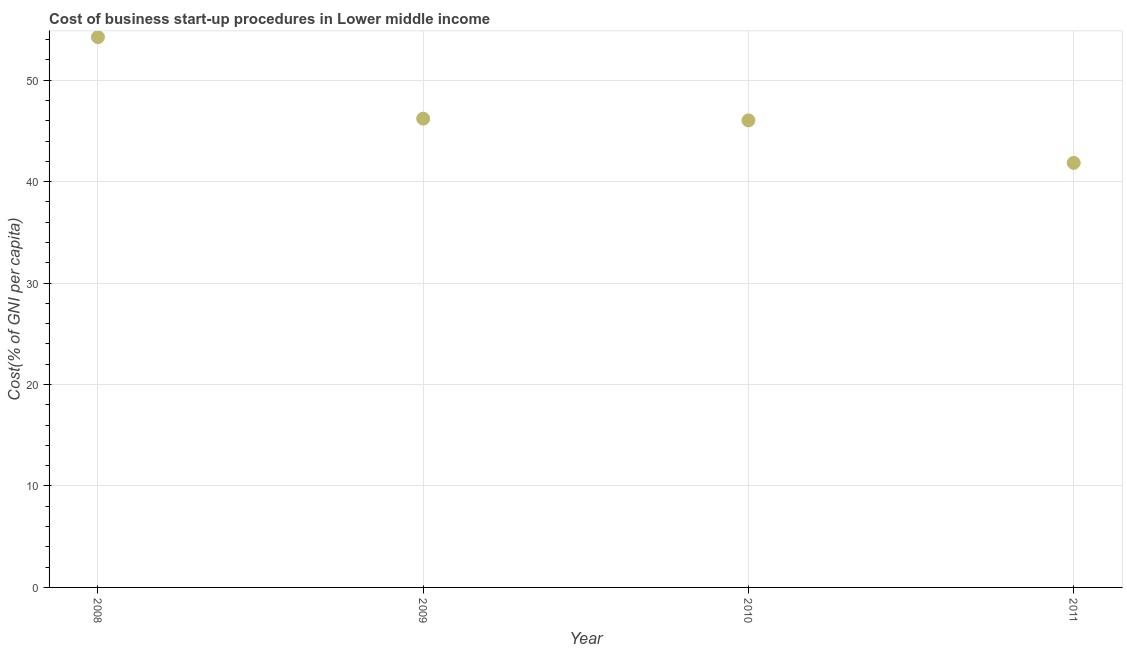What is the cost of business startup procedures in 2010?
Offer a very short reply. 46.04. Across all years, what is the maximum cost of business startup procedures?
Keep it short and to the point. 54.24. Across all years, what is the minimum cost of business startup procedures?
Ensure brevity in your answer.  41.85. In which year was the cost of business startup procedures maximum?
Your response must be concise. 2008. What is the sum of the cost of business startup procedures?
Keep it short and to the point. 188.33. What is the difference between the cost of business startup procedures in 2008 and 2009?
Provide a short and direct response. 8.04. What is the average cost of business startup procedures per year?
Your answer should be compact. 47.08. What is the median cost of business startup procedures?
Make the answer very short. 46.12. What is the ratio of the cost of business startup procedures in 2009 to that in 2010?
Your answer should be compact. 1. Is the cost of business startup procedures in 2009 less than that in 2010?
Give a very brief answer. No. What is the difference between the highest and the second highest cost of business startup procedures?
Provide a short and direct response. 8.04. What is the difference between the highest and the lowest cost of business startup procedures?
Give a very brief answer. 12.4. How many years are there in the graph?
Offer a terse response. 4. Are the values on the major ticks of Y-axis written in scientific E-notation?
Make the answer very short. No. Does the graph contain any zero values?
Your response must be concise. No. What is the title of the graph?
Ensure brevity in your answer.  Cost of business start-up procedures in Lower middle income. What is the label or title of the Y-axis?
Provide a short and direct response. Cost(% of GNI per capita). What is the Cost(% of GNI per capita) in 2008?
Your answer should be compact. 54.24. What is the Cost(% of GNI per capita) in 2009?
Your response must be concise. 46.21. What is the Cost(% of GNI per capita) in 2010?
Offer a terse response. 46.04. What is the Cost(% of GNI per capita) in 2011?
Provide a succinct answer. 41.85. What is the difference between the Cost(% of GNI per capita) in 2008 and 2009?
Your answer should be compact. 8.04. What is the difference between the Cost(% of GNI per capita) in 2008 and 2010?
Offer a terse response. 8.21. What is the difference between the Cost(% of GNI per capita) in 2008 and 2011?
Provide a short and direct response. 12.4. What is the difference between the Cost(% of GNI per capita) in 2009 and 2010?
Keep it short and to the point. 0.17. What is the difference between the Cost(% of GNI per capita) in 2009 and 2011?
Your response must be concise. 4.36. What is the difference between the Cost(% of GNI per capita) in 2010 and 2011?
Your response must be concise. 4.19. What is the ratio of the Cost(% of GNI per capita) in 2008 to that in 2009?
Offer a very short reply. 1.17. What is the ratio of the Cost(% of GNI per capita) in 2008 to that in 2010?
Your answer should be very brief. 1.18. What is the ratio of the Cost(% of GNI per capita) in 2008 to that in 2011?
Provide a succinct answer. 1.3. What is the ratio of the Cost(% of GNI per capita) in 2009 to that in 2010?
Ensure brevity in your answer.  1. What is the ratio of the Cost(% of GNI per capita) in 2009 to that in 2011?
Your answer should be compact. 1.1. 